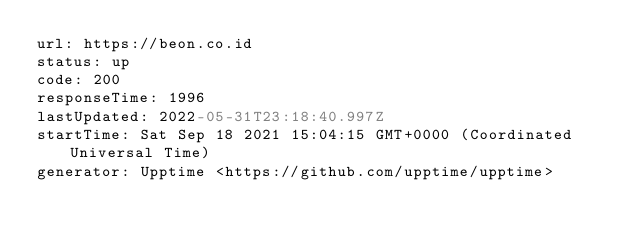<code> <loc_0><loc_0><loc_500><loc_500><_YAML_>url: https://beon.co.id
status: up
code: 200
responseTime: 1996
lastUpdated: 2022-05-31T23:18:40.997Z
startTime: Sat Sep 18 2021 15:04:15 GMT+0000 (Coordinated Universal Time)
generator: Upptime <https://github.com/upptime/upptime>
</code> 